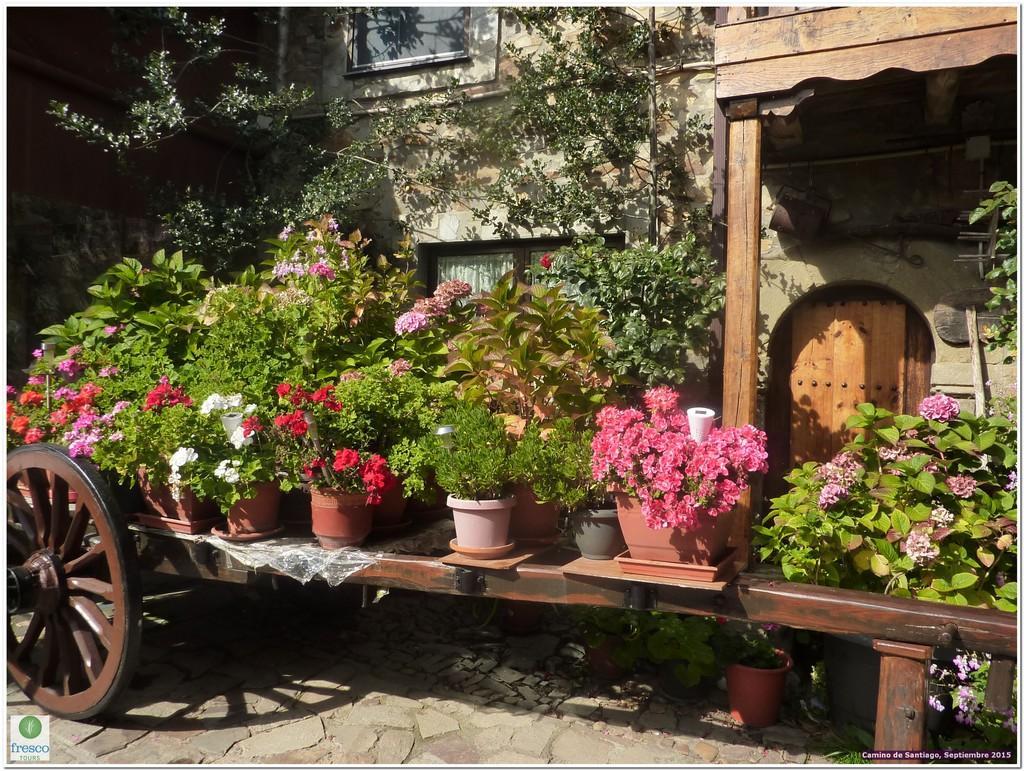Can you describe this image briefly? In the picture there is a cart, on the cart there are many house plants present, there are flowers present, beside the car there are trees, there may be a building, there are glass windows present on the wall. 